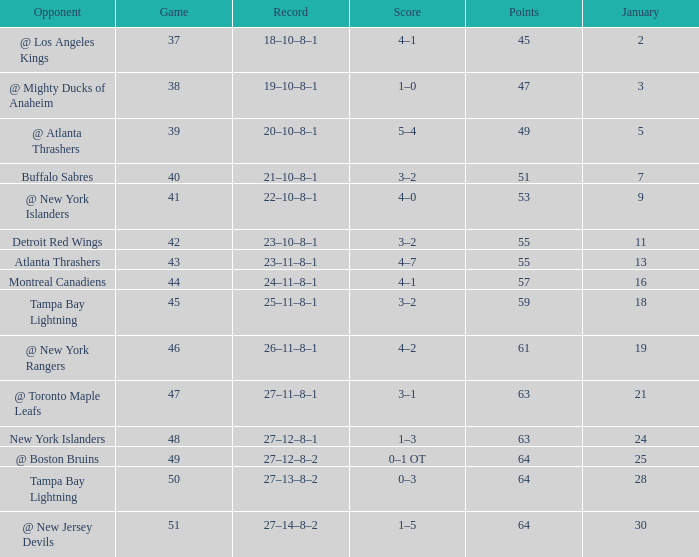Which Points have a Score of 4–1, and a Record of 18–10–8–1, and a January larger than 2? None. 